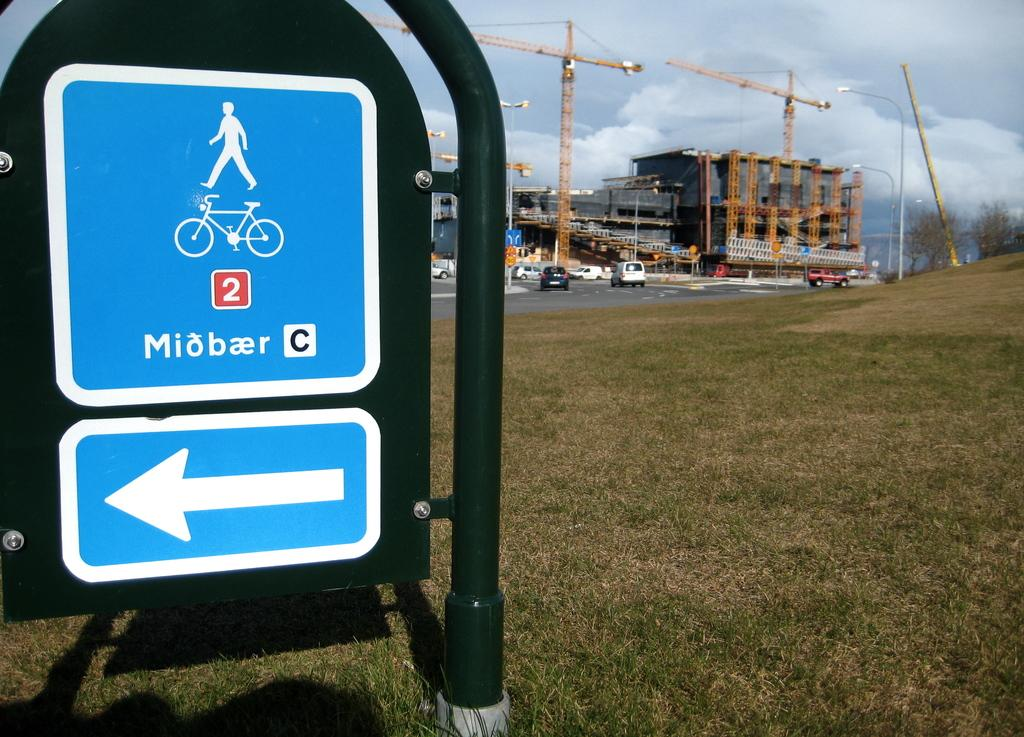<image>
Relay a brief, clear account of the picture shown. A blue bicycle sign outside a construction site. 